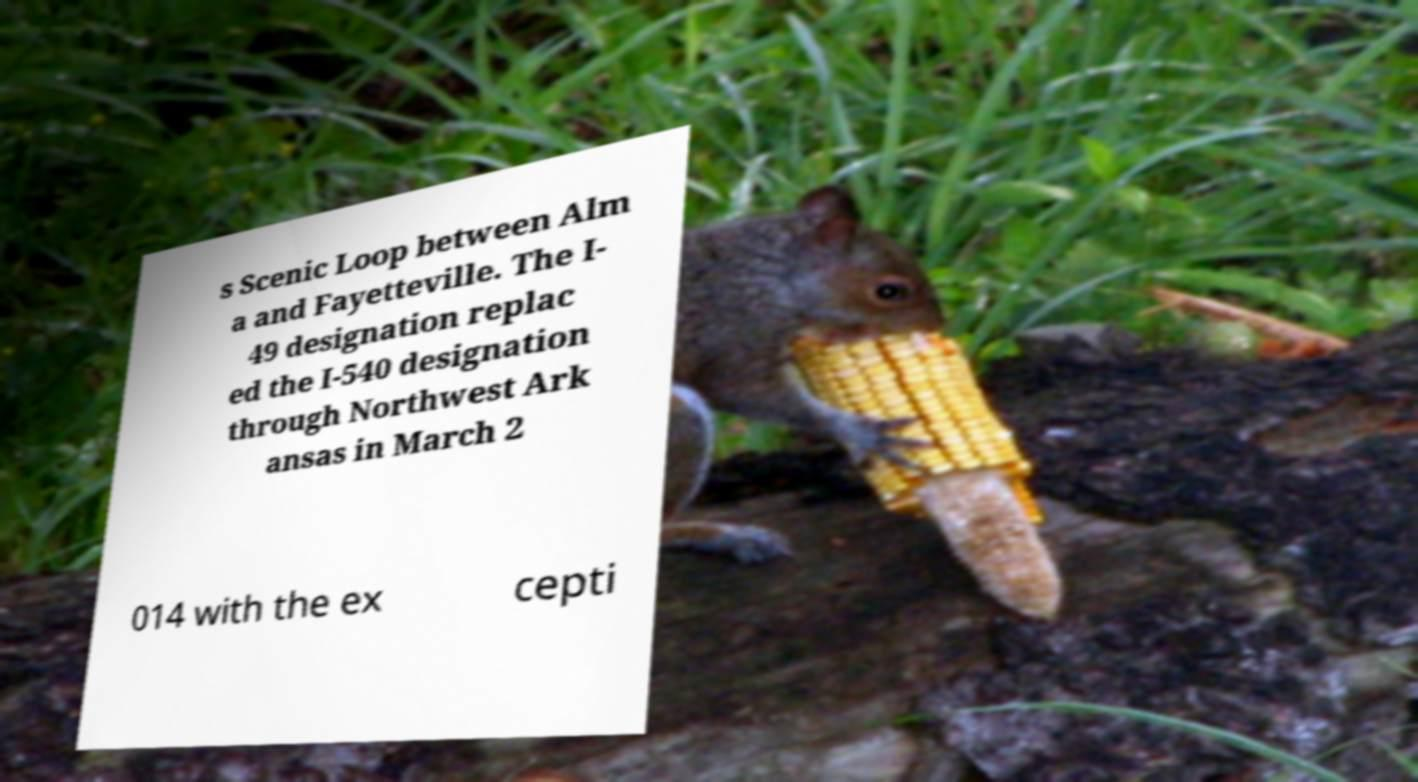Could you assist in decoding the text presented in this image and type it out clearly? s Scenic Loop between Alm a and Fayetteville. The I- 49 designation replac ed the I-540 designation through Northwest Ark ansas in March 2 014 with the ex cepti 